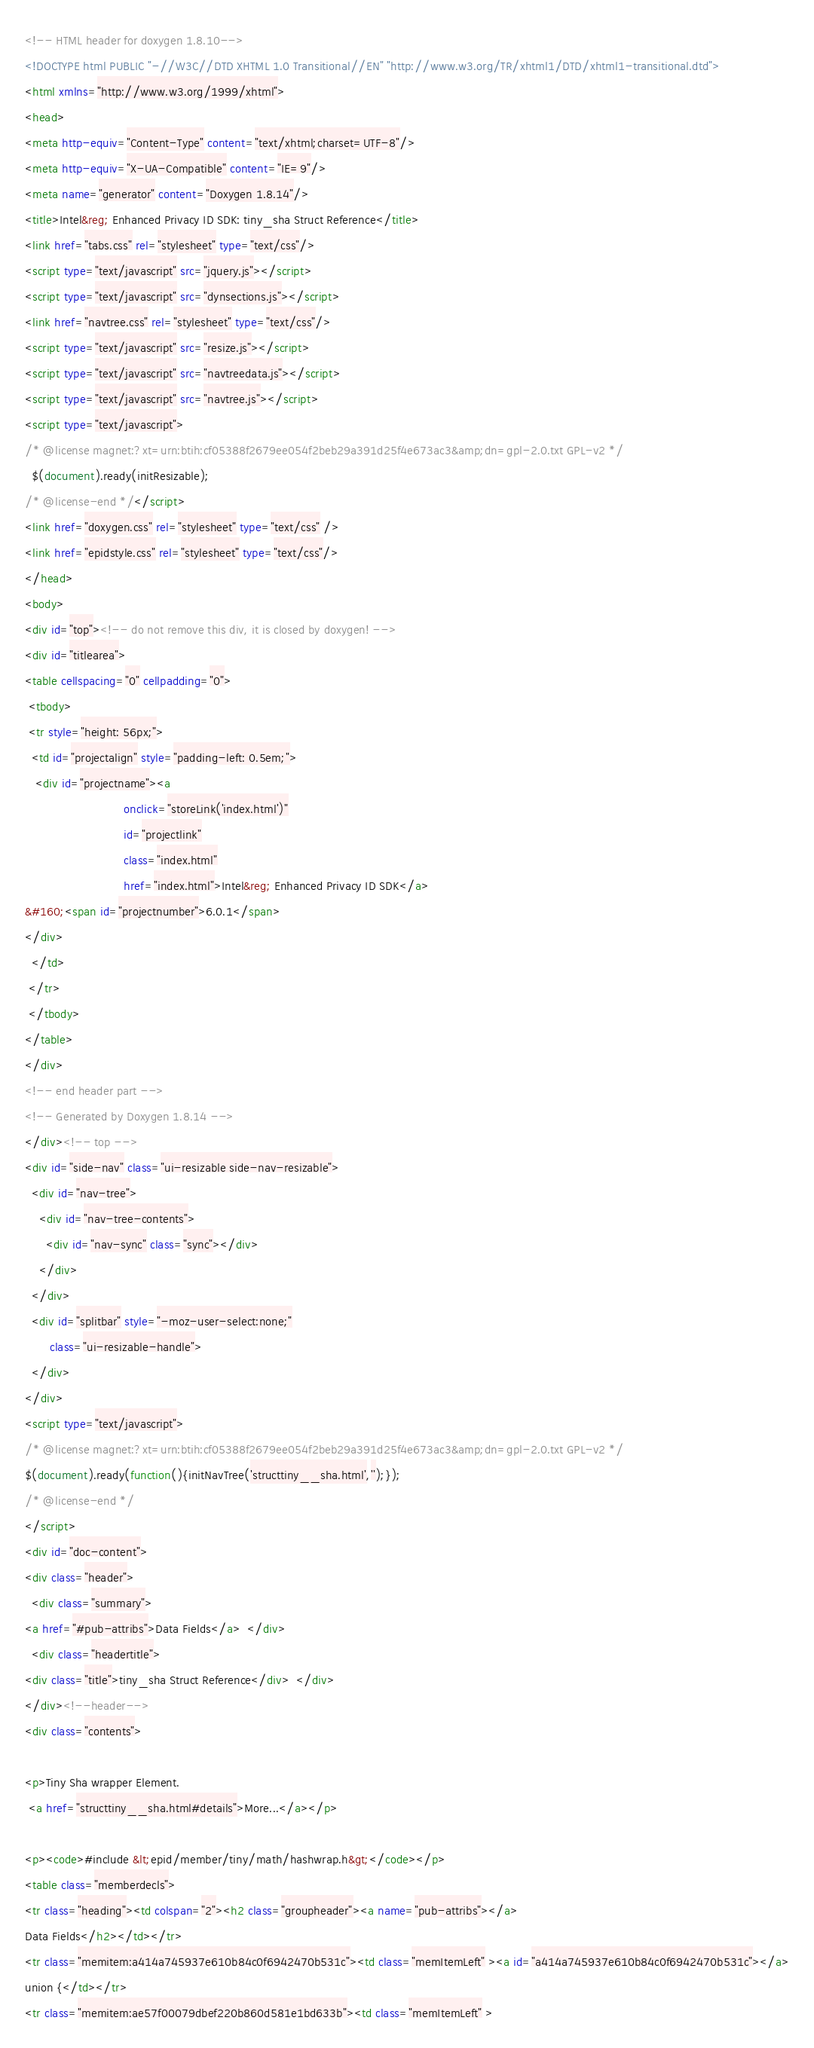<code> <loc_0><loc_0><loc_500><loc_500><_HTML_><!-- HTML header for doxygen 1.8.10-->
<!DOCTYPE html PUBLIC "-//W3C//DTD XHTML 1.0 Transitional//EN" "http://www.w3.org/TR/xhtml1/DTD/xhtml1-transitional.dtd">
<html xmlns="http://www.w3.org/1999/xhtml">
<head>
<meta http-equiv="Content-Type" content="text/xhtml;charset=UTF-8"/>
<meta http-equiv="X-UA-Compatible" content="IE=9"/>
<meta name="generator" content="Doxygen 1.8.14"/>
<title>Intel&reg; Enhanced Privacy ID SDK: tiny_sha Struct Reference</title>
<link href="tabs.css" rel="stylesheet" type="text/css"/>
<script type="text/javascript" src="jquery.js"></script>
<script type="text/javascript" src="dynsections.js"></script>
<link href="navtree.css" rel="stylesheet" type="text/css"/>
<script type="text/javascript" src="resize.js"></script>
<script type="text/javascript" src="navtreedata.js"></script>
<script type="text/javascript" src="navtree.js"></script>
<script type="text/javascript">
/* @license magnet:?xt=urn:btih:cf05388f2679ee054f2beb29a391d25f4e673ac3&amp;dn=gpl-2.0.txt GPL-v2 */
  $(document).ready(initResizable);
/* @license-end */</script>
<link href="doxygen.css" rel="stylesheet" type="text/css" />
<link href="epidstyle.css" rel="stylesheet" type="text/css"/>
</head>
<body>
<div id="top"><!-- do not remove this div, it is closed by doxygen! -->
<div id="titlearea">
<table cellspacing="0" cellpadding="0">
 <tbody>
 <tr style="height: 56px;">
  <td id="projectalign" style="padding-left: 0.5em;">
   <div id="projectname"><a 
                            onclick="storeLink('index.html')"
                            id="projectlink" 
                            class="index.html" 
                            href="index.html">Intel&reg; Enhanced Privacy ID SDK</a>
&#160;<span id="projectnumber">6.0.1</span>
</div>
  </td>
 </tr>
 </tbody>
</table>
</div>
<!-- end header part -->
<!-- Generated by Doxygen 1.8.14 -->
</div><!-- top -->
<div id="side-nav" class="ui-resizable side-nav-resizable">
  <div id="nav-tree">
    <div id="nav-tree-contents">
      <div id="nav-sync" class="sync"></div>
    </div>
  </div>
  <div id="splitbar" style="-moz-user-select:none;" 
       class="ui-resizable-handle">
  </div>
</div>
<script type="text/javascript">
/* @license magnet:?xt=urn:btih:cf05388f2679ee054f2beb29a391d25f4e673ac3&amp;dn=gpl-2.0.txt GPL-v2 */
$(document).ready(function(){initNavTree('structtiny__sha.html','');});
/* @license-end */
</script>
<div id="doc-content">
<div class="header">
  <div class="summary">
<a href="#pub-attribs">Data Fields</a>  </div>
  <div class="headertitle">
<div class="title">tiny_sha Struct Reference</div>  </div>
</div><!--header-->
<div class="contents">

<p>Tiny Sha wrapper Element.  
 <a href="structtiny__sha.html#details">More...</a></p>

<p><code>#include &lt;epid/member/tiny/math/hashwrap.h&gt;</code></p>
<table class="memberdecls">
<tr class="heading"><td colspan="2"><h2 class="groupheader"><a name="pub-attribs"></a>
Data Fields</h2></td></tr>
<tr class="memitem:a414a745937e610b84c0f6942470b531c"><td class="memItemLeft" ><a id="a414a745937e610b84c0f6942470b531c"></a>
union {</td></tr>
<tr class="memitem:ae57f00079dbef220b860d581e1bd633b"><td class="memItemLeft" ></code> 